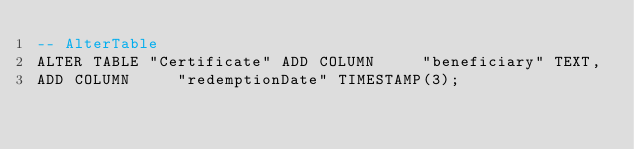Convert code to text. <code><loc_0><loc_0><loc_500><loc_500><_SQL_>-- AlterTable
ALTER TABLE "Certificate" ADD COLUMN     "beneficiary" TEXT,
ADD COLUMN     "redemptionDate" TIMESTAMP(3);
</code> 